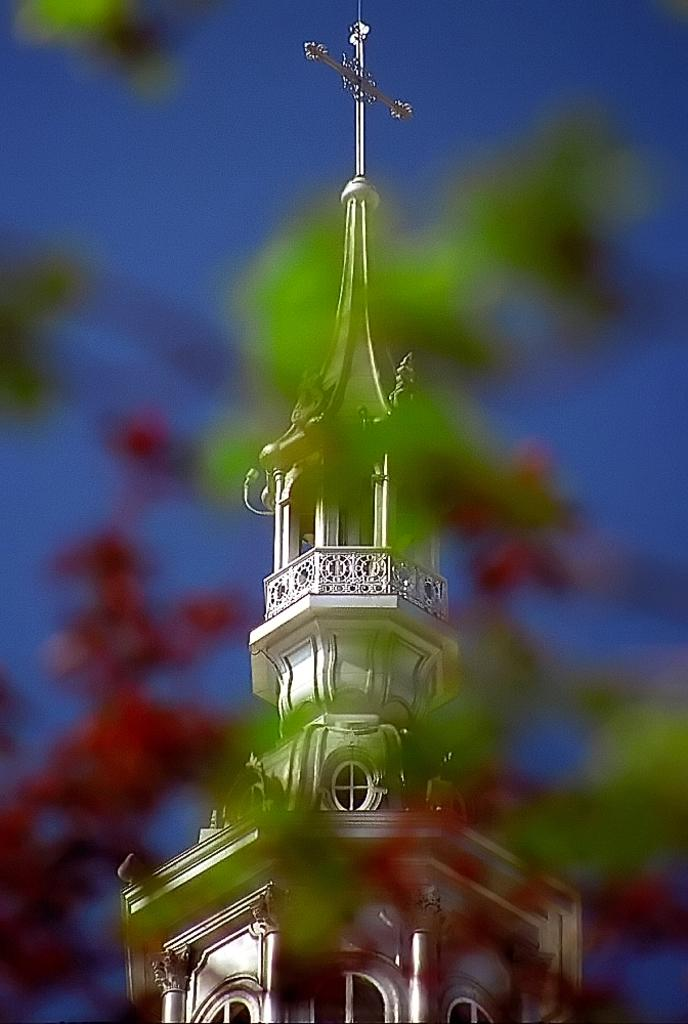What is the main structure in the picture? There is a tower in the picture. What can be seen in the background of the picture? The sky is visible in the background of the picture. How many oranges are hanging from the basket in the picture? There is no basket or orange present in the picture; it features a tower and the sky. What type of star can be seen in the picture? There is no star present in the picture; it features a tower and the sky. 